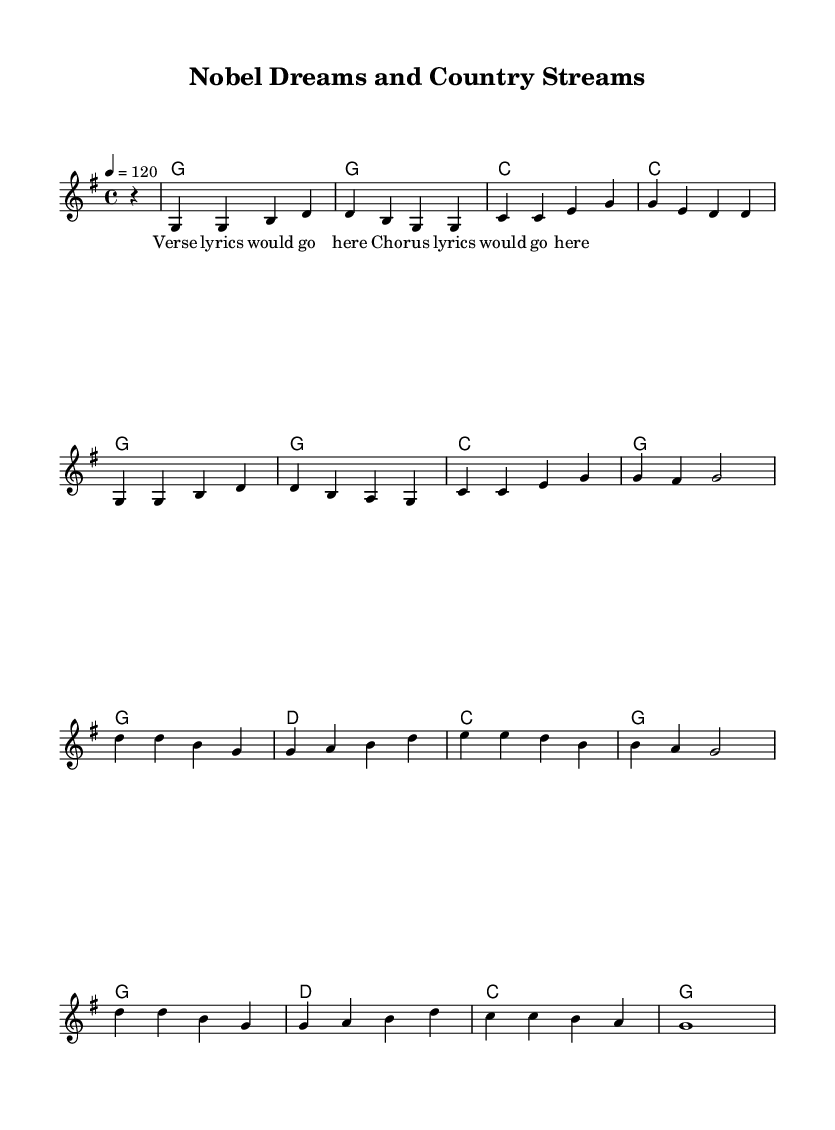What is the key signature of this music? The key signature at the beginning of the score indicates that the piece is in G major, which has one sharp (F#).
Answer: G major What is the time signature of this music? The time signature shown at the beginning of the score is 4/4, meaning there are four beats per measure.
Answer: 4/4 What is the tempo marking of this music? The tempo marking indicates that the piece should be played at a speed of 120 beats per minute.
Answer: 120 How many measures are in the melody section? By counting the distinct sections in the melody, we find there are eight measures.
Answer: 8 What note values are primarily used in the melody? The predominant note value in the melody is the quarter note, as seen in each measure.
Answer: Quarter note What themes are explored in the lyrics of this country song? The lyrics suggest themes of balancing career aspirations with personal life, reflecting the struggles faced in academia.
Answer: Balance between career and personal life How many chords are used in the harmonies section? Upon reviewing the harmony section, there are a total of five unique chords utilized throughout the piece.
Answer: 5 